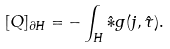Convert formula to latex. <formula><loc_0><loc_0><loc_500><loc_500>[ Q ] _ { \partial H } = - \int _ { H } { \hat { * } } g ( j , \hat { \tau } ) .</formula> 